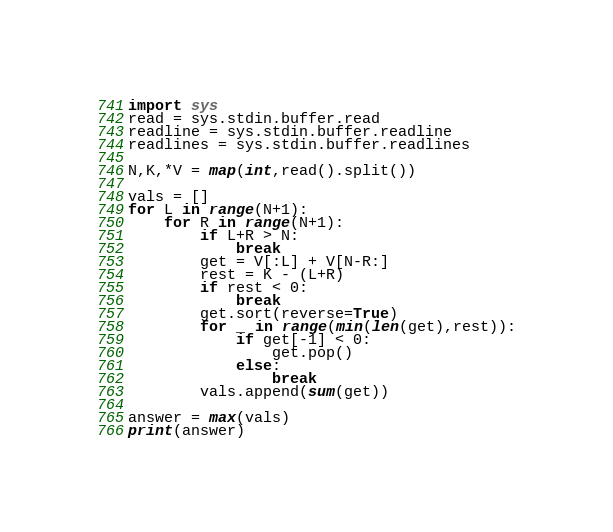<code> <loc_0><loc_0><loc_500><loc_500><_Python_>import sys
read = sys.stdin.buffer.read
readline = sys.stdin.buffer.readline
readlines = sys.stdin.buffer.readlines

N,K,*V = map(int,read().split())

vals = []
for L in range(N+1):
    for R in range(N+1):
        if L+R > N:
            break
        get = V[:L] + V[N-R:]
        rest = K - (L+R)
        if rest < 0:
            break
        get.sort(reverse=True)
        for _ in range(min(len(get),rest)):
            if get[-1] < 0:
                get.pop()
            else:
                break
        vals.append(sum(get))

answer = max(vals)
print(answer)
</code> 